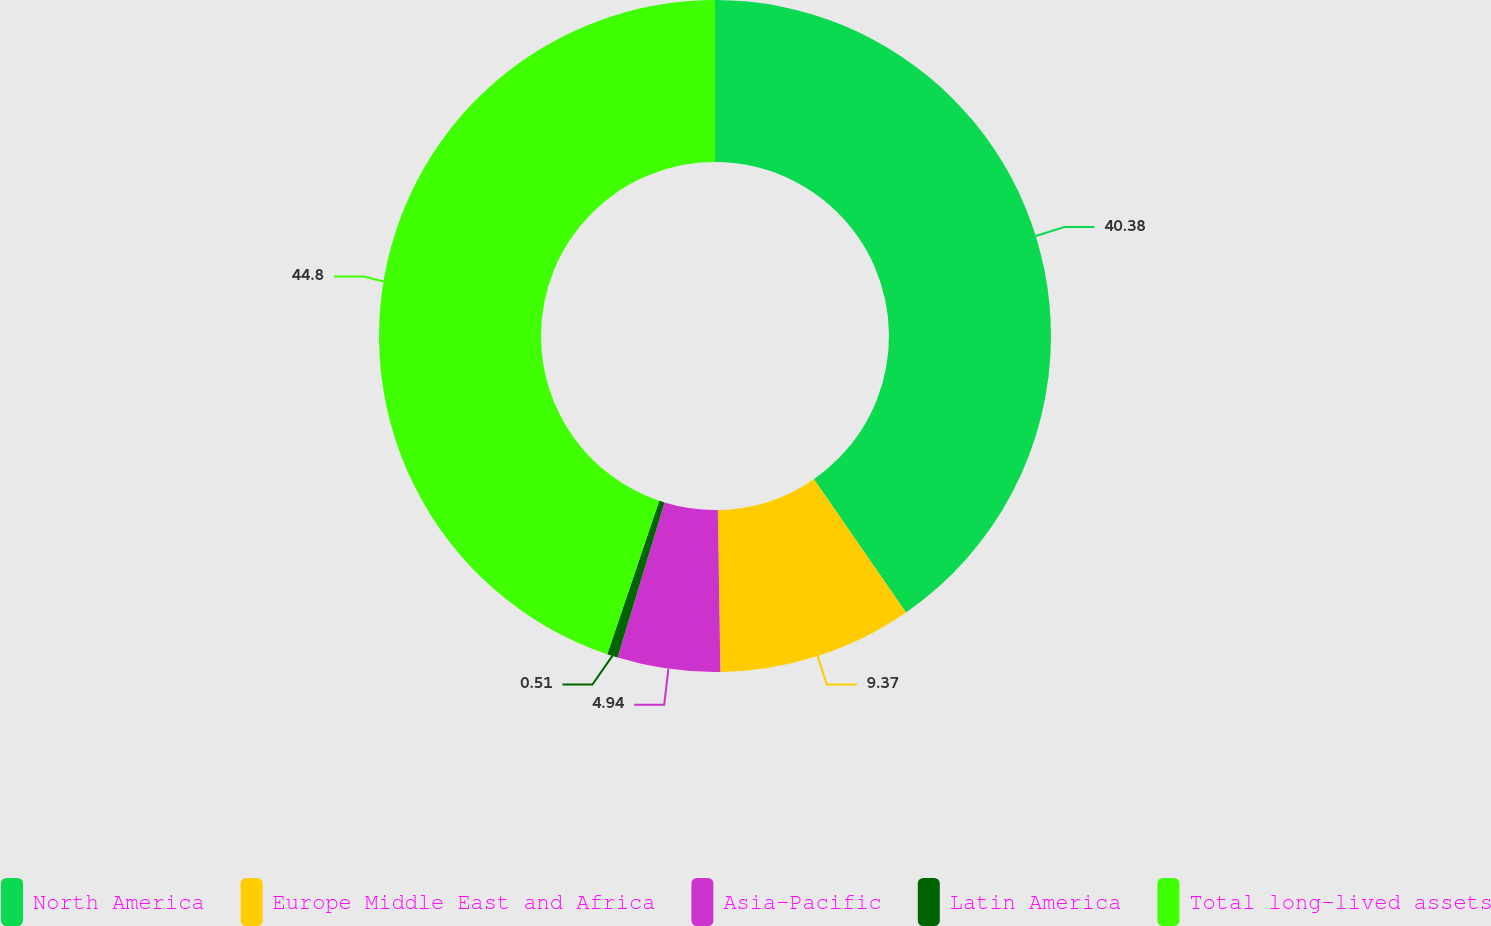Convert chart to OTSL. <chart><loc_0><loc_0><loc_500><loc_500><pie_chart><fcel>North America<fcel>Europe Middle East and Africa<fcel>Asia-Pacific<fcel>Latin America<fcel>Total long-lived assets<nl><fcel>40.38%<fcel>9.37%<fcel>4.94%<fcel>0.51%<fcel>44.81%<nl></chart> 